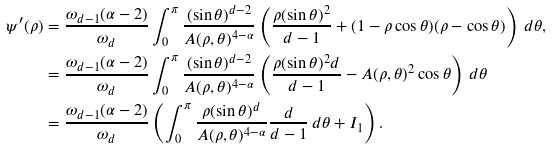<formula> <loc_0><loc_0><loc_500><loc_500>\psi ^ { \prime } ( \rho ) & = \frac { \omega _ { d - 1 } ( \alpha - 2 ) } { \omega _ { d } } \int _ { 0 } ^ { \pi } \frac { ( \sin \theta ) ^ { d - 2 } } { A ( \rho , \theta ) ^ { 4 - \alpha } } \left ( \frac { \rho ( \sin \theta ) ^ { 2 } } { d - 1 } + ( 1 - \rho \cos \theta ) ( \rho - \cos \theta ) \right ) \, d \theta , \\ & = \frac { \omega _ { d - 1 } ( \alpha - 2 ) } { \omega _ { d } } \int _ { 0 } ^ { \pi } \frac { ( \sin \theta ) ^ { d - 2 } } { A ( \rho , \theta ) ^ { 4 - \alpha } } \left ( \frac { \rho ( \sin \theta ) ^ { 2 } d } { d - 1 } - A ( \rho , \theta ) ^ { 2 } \cos \theta \right ) \, d \theta \\ & = \frac { \omega _ { d - 1 } ( \alpha - 2 ) } { \omega _ { d } } \left ( \int _ { 0 } ^ { \pi } \frac { \rho ( \sin \theta ) ^ { d } } { A ( \rho , \theta ) ^ { 4 - \alpha } } \frac { d } { d - 1 } \, d \theta + I _ { 1 } \right ) .</formula> 